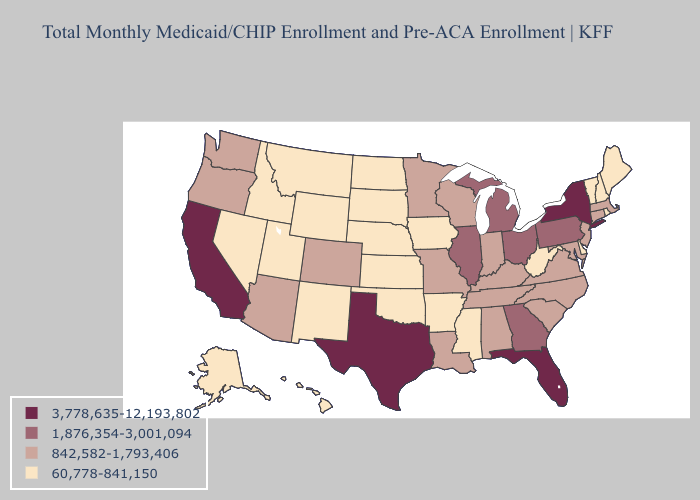Does the map have missing data?
Write a very short answer. No. Does Nebraska have the lowest value in the USA?
Answer briefly. Yes. Name the states that have a value in the range 1,876,354-3,001,094?
Be succinct. Georgia, Illinois, Michigan, Ohio, Pennsylvania. Which states have the lowest value in the West?
Answer briefly. Alaska, Hawaii, Idaho, Montana, Nevada, New Mexico, Utah, Wyoming. Name the states that have a value in the range 1,876,354-3,001,094?
Concise answer only. Georgia, Illinois, Michigan, Ohio, Pennsylvania. Among the states that border New Hampshire , which have the highest value?
Short answer required. Massachusetts. What is the value of Delaware?
Answer briefly. 60,778-841,150. Does Mississippi have a higher value than Massachusetts?
Quick response, please. No. Which states have the lowest value in the South?
Write a very short answer. Arkansas, Delaware, Mississippi, Oklahoma, West Virginia. Does the first symbol in the legend represent the smallest category?
Be succinct. No. Does Oklahoma have the lowest value in the South?
Concise answer only. Yes. Does California have a higher value than Florida?
Short answer required. No. Is the legend a continuous bar?
Quick response, please. No. Does Louisiana have the lowest value in the USA?
Give a very brief answer. No. Name the states that have a value in the range 842,582-1,793,406?
Be succinct. Alabama, Arizona, Colorado, Connecticut, Indiana, Kentucky, Louisiana, Maryland, Massachusetts, Minnesota, Missouri, New Jersey, North Carolina, Oregon, South Carolina, Tennessee, Virginia, Washington, Wisconsin. 